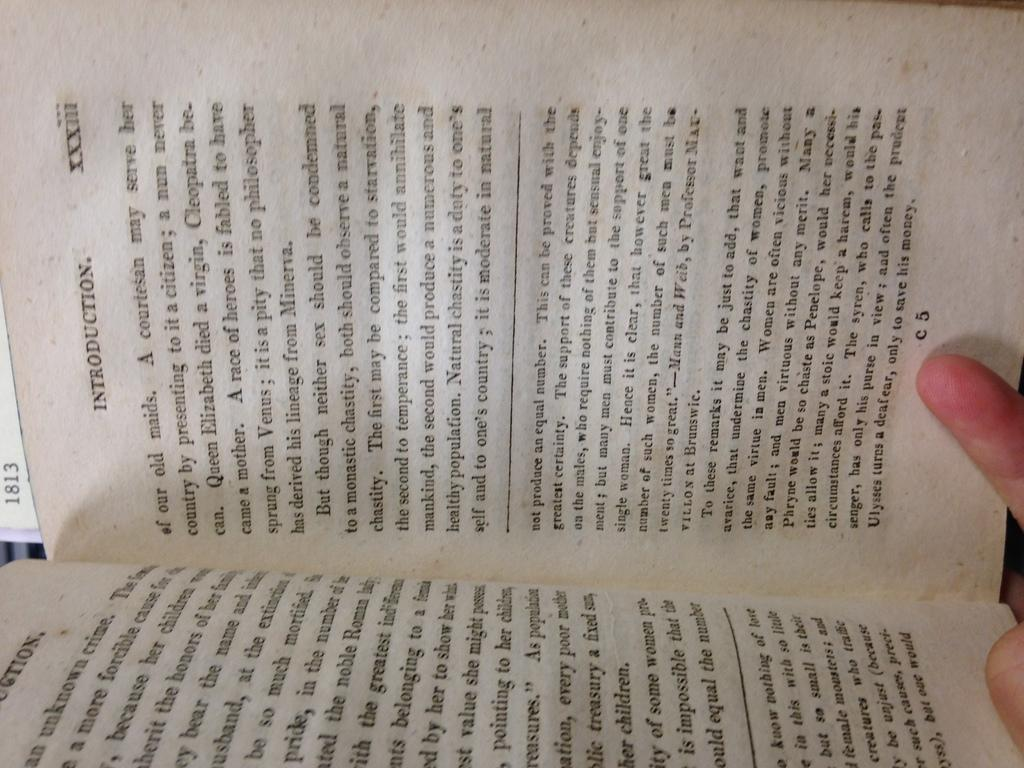What type of object is depicted in the image? The image contains pages of a book. Can you describe the content of the book? There is writing on the pages of the book. Are there any visible signs of interaction with the book? Yes, there are fingers of a person on the right side of the image. What type of society is depicted in the image? There is no society depicted in the image; it only contains pages of a book with writing and fingers on the right side. Can you describe the experience of the person driving the van in the image? There is no van or person driving in the image; it only contains pages of a book with writing and fingers on the right side. 